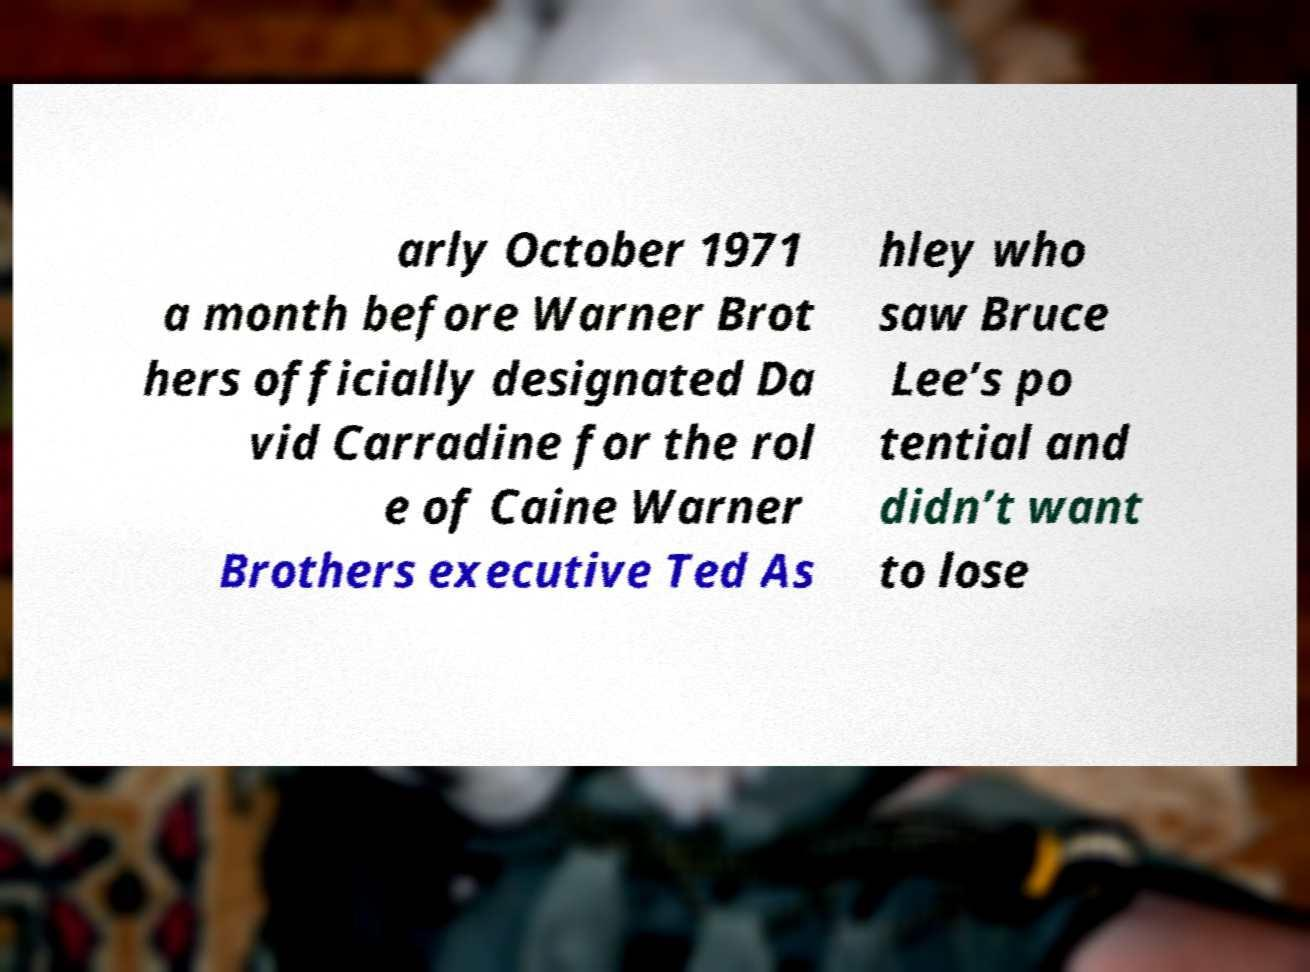What messages or text are displayed in this image? I need them in a readable, typed format. arly October 1971 a month before Warner Brot hers officially designated Da vid Carradine for the rol e of Caine Warner Brothers executive Ted As hley who saw Bruce Lee’s po tential and didn’t want to lose 